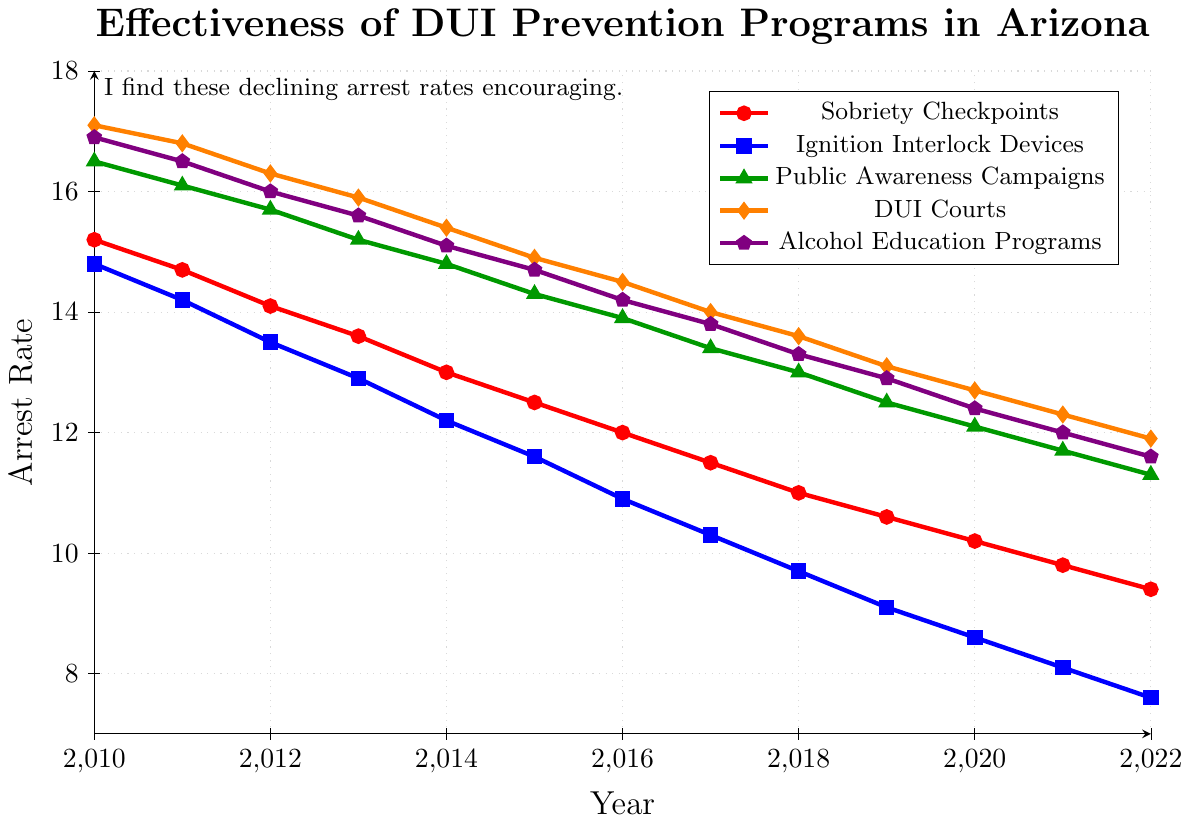What DUI prevention program had the highest arrest rate in 2010? To find the highest arrest rate in 2010, look for the highest point on the graph for the year 2010. Sobriety Checkpoints have an arrest rate of 15.2, Ignition Interlock Devices have 14.8, Public Awareness Campaigns have 16.5, DUI Courts have 17.1, and Alcohol Education Programs have 16.9. The highest rate is for DUI Courts.
Answer: DUI Courts Between 2010 and 2022, which DUI prevention program showed the largest decrease in arrest rates? Calculate the difference in arrest rates from 2010 to 2022 for each program. Sobriety Checkpoints decreased by 15.2 - 9.4 = 5.8, Ignition Interlock Devices decreased by 14.8 - 7.6 = 7.2, Public Awareness Campaigns decreased by 16.5 - 11.3 = 5.2, DUI Courts decreased by 17.1 - 11.9 = 5.2, and Alcohol Education Programs decreased by 16.9 - 11.6 = 5.3. The largest decrease is for Ignition Interlock Devices.
Answer: Ignition Interlock Devices What is the average arrest rate for Sobriety Checkpoints from 2010 to 2022? To find the average, sum the arrest rates for Sobriety Checkpoints from 2010 to 2022 and divide by the number of years. The rates are 15.2, 14.7, 14.1, 13.6, 13.0, 12.5, 12.0, 11.5, 11.0, 10.6, 10.2, 9.8, 9.4. The sum is 157.6, and there are 13 years. The average is 157.6 / 13 ≈ 12.1.
Answer: 12.1 In 2015, which two programs had the smallest difference in their arrest rates? Calculate the differences between the arrest rates for each pair of programs in 2015. The arrest rates are Sobriety Checkpoints: 12.5, Ignition Interlock Devices: 11.6, Public Awareness Campaigns: 14.3, DUI Courts: 14.9, Alcohol Education Programs: 14.7. The differences are Sobriety Checkpoints and Ignition Interlock Devices: 0.9, Sobriety Checkpoints and Public Awareness Campaigns: 1.8, Sobriety Checkpoints and DUI Courts: 2.4, Sobriety Checkpoints and Alcohol Education Programs: 2.2, Ignition Interlock Devices and Public Awareness Campaigns: 2.7, Ignition Interlock Devices and DUI Courts: 3.3, Ignition Interlock Devices and Alcohol Education Programs: 3.1, Public Awareness Campaigns and DUI Courts: 0.6, Public Awareness Campaigns and Alcohol Education Programs: 0.4, DUI Courts and Alcohol Education Programs: 0.2. The smallest difference is between DUI Courts and Alcohol Education Programs.
Answer: DUI Courts and Alcohol Education Programs Which program had a consistently decreasing arrest rate every year from 2010 to 2022? Check the data points for each program. Sobriety Checkpoints, Ignition Interlock Devices, Public Awareness Campaigns, DUI Courts, and Alcohol Education Programs all show a consistent decrease each year. So all the programs listed had a consistently decreasing arrest rate.
Answer: All programs Was the arrest rate for Alcohol Education Programs ever higher than Public Awareness Campaigns between 2010 and 2022? Compare the arrest rates for Alcohol Education Programs and Public Awareness Campaigns each year. The arrest rates for Alcohol Education Programs are always lower than Public Awareness Campaigns.
Answer: No What was the trend in arrest rates for DUI Courts from 2010 to 2022? To identify the trend, look at how the arrest rate changes over the years. For DUI Courts, the rates consistently decrease from 17.1 in 2010 to 11.9 in 2022. The trend is a steady decline.
Answer: Steady decline If the trend continues, what could be the potential arrest rate for Ignition Interlock Devices in 2023? To project the arrest rate, calculate the average yearly decrease for Ignition Interlock Devices from 2010 to 2022. The arrest rate decreased from 14.8 to 7.6, a total decrease of 7.2 over 12 years, giving an average yearly decrease of 7.2 / 12 ≈ 0.6. If the trend continues, the arrest rate in 2023 could be 7.6 - 0.6 = 7.0.
Answer: 7.0 Which year did Sobriety Checkpoints and DUI Courts have the same arrest rate? Compare the arrest rates of Sobriety Checkpoints and DUI Courts for each year. In 2019, both have the same arrest rate of 13.1.
Answer: 2019 How does the arrest rate of Public Awareness Campaigns in 2012 compare to that of Alcohol Education Programs in 2022? Check the arrest rates for the specified years: Public Awareness Campaigns in 2012 is 15.7 and Alcohol Education Programs in 2022 is 11.6. The arrest rate for Public Awareness Campaigns in 2012 is higher.
Answer: Public Awareness Campaigns in 2012 is higher 